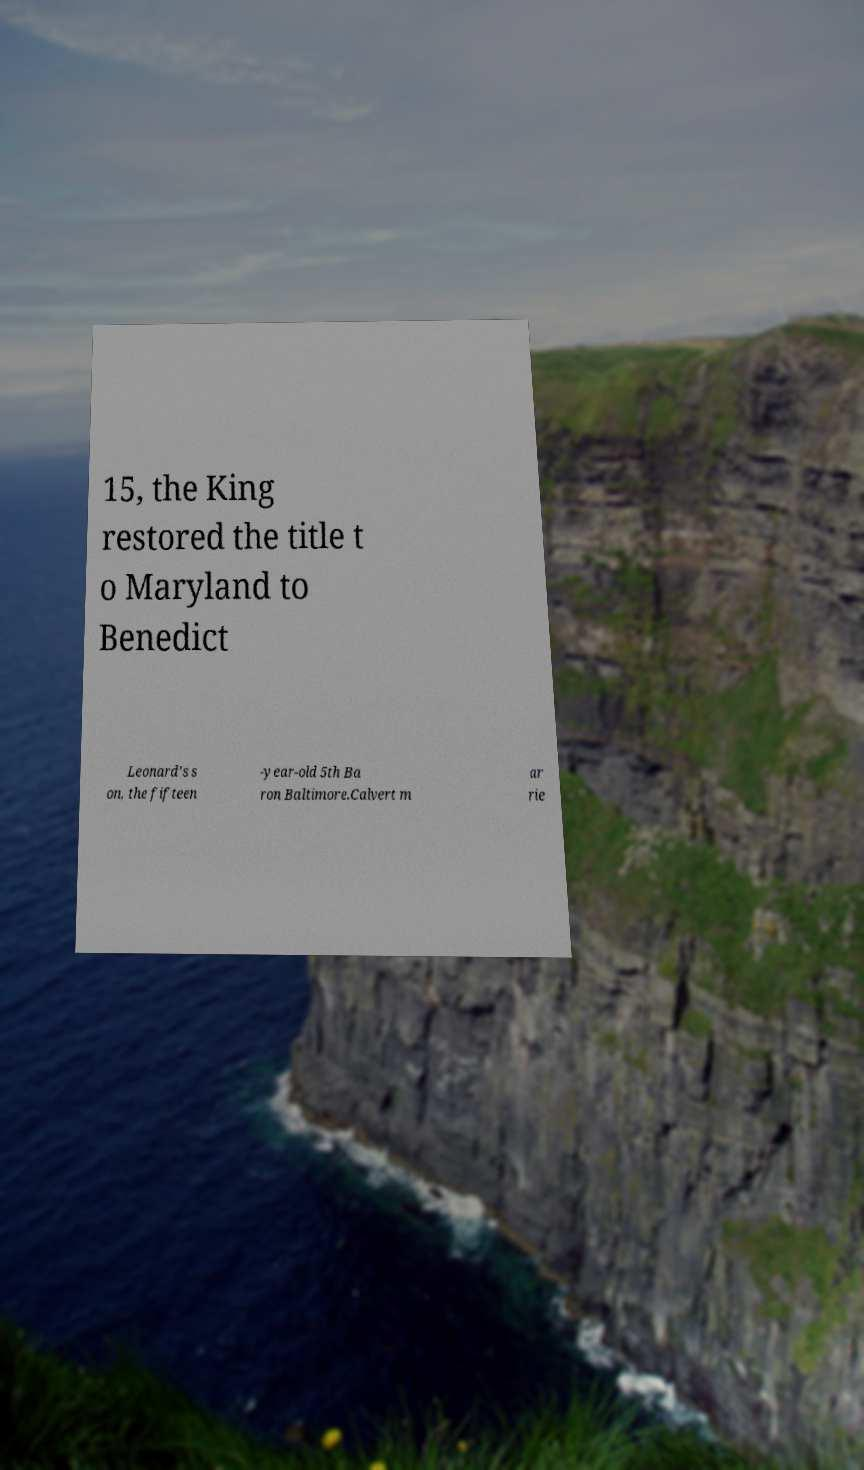Could you assist in decoding the text presented in this image and type it out clearly? 15, the King restored the title t o Maryland to Benedict Leonard's s on, the fifteen -year-old 5th Ba ron Baltimore.Calvert m ar rie 